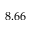Convert formula to latex. <formula><loc_0><loc_0><loc_500><loc_500>8 . 6 6</formula> 